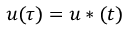<formula> <loc_0><loc_0><loc_500><loc_500>u ( \tau ) = u * ( t )</formula> 